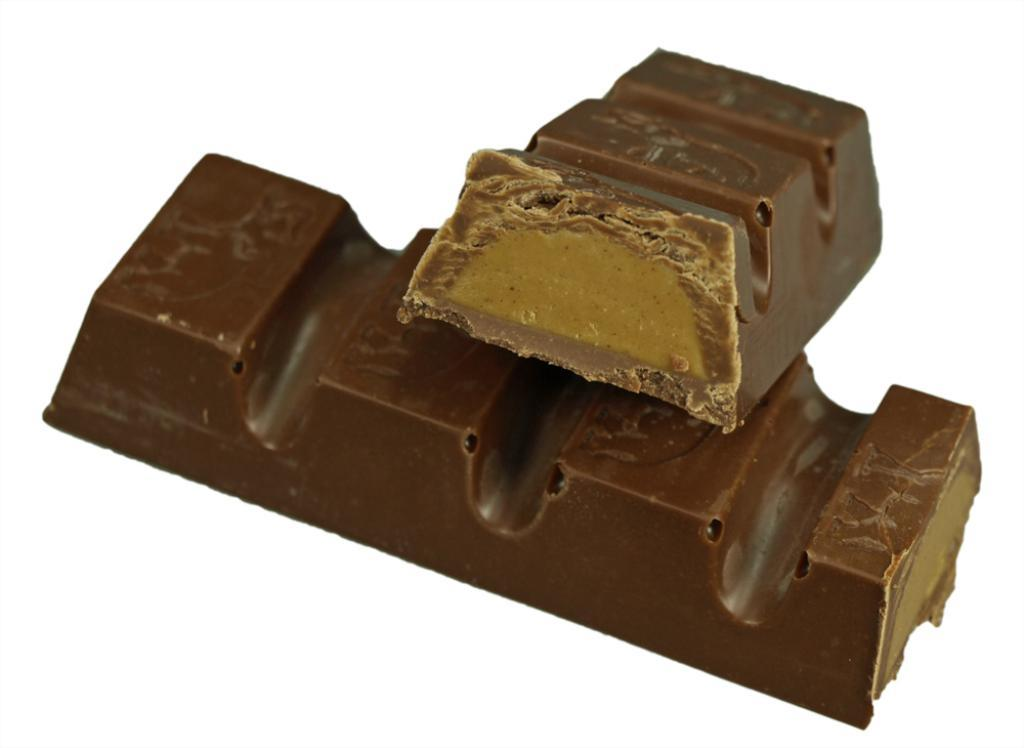What type of food can be seen in the image? There are chocolates in the image. What color is the background of the image? The background of the image is white. How many hens are present in the image? There are no hens present in the image; it features chocolates and a white background. What type of trade is being conducted in the image? There is no trade being conducted in the image; it features chocolates and a white background. 